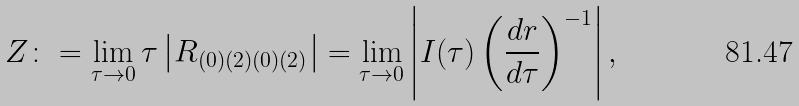<formula> <loc_0><loc_0><loc_500><loc_500>Z \colon = \lim _ { \tau \rightarrow 0 } \tau \left | R _ { ( 0 ) ( 2 ) ( 0 ) ( 2 ) } \right | = \lim _ { \tau \rightarrow 0 } \left | I ( \tau ) \left ( \frac { d r } { d \tau } \right ) ^ { - 1 } \right | ,</formula> 